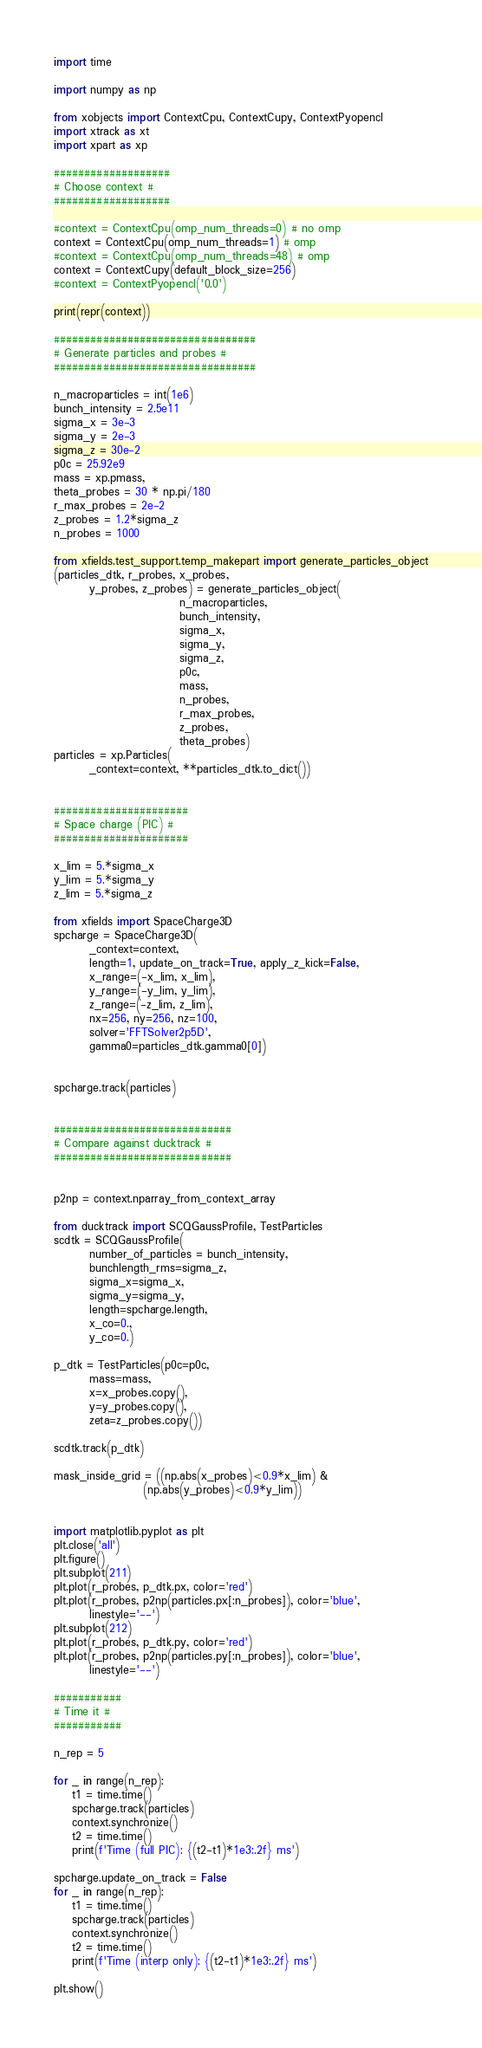<code> <loc_0><loc_0><loc_500><loc_500><_Python_>import time

import numpy as np

from xobjects import ContextCpu, ContextCupy, ContextPyopencl
import xtrack as xt
import xpart as xp

###################
# Choose context #
###################

#context = ContextCpu(omp_num_threads=0) # no omp
context = ContextCpu(omp_num_threads=1) # omp
#context = ContextCpu(omp_num_threads=48) # omp
context = ContextCupy(default_block_size=256)
#context = ContextPyopencl('0.0')

print(repr(context))

#################################
# Generate particles and probes #
#################################

n_macroparticles = int(1e6)
bunch_intensity = 2.5e11
sigma_x = 3e-3
sigma_y = 2e-3
sigma_z = 30e-2
p0c = 25.92e9
mass = xp.pmass,
theta_probes = 30 * np.pi/180
r_max_probes = 2e-2
z_probes = 1.2*sigma_z
n_probes = 1000

from xfields.test_support.temp_makepart import generate_particles_object
(particles_dtk, r_probes, x_probes,
        y_probes, z_probes) = generate_particles_object(
                            n_macroparticles,
                            bunch_intensity,
                            sigma_x,
                            sigma_y,
                            sigma_z,
                            p0c,
                            mass,
                            n_probes,
                            r_max_probes,
                            z_probes,
                            theta_probes)
particles = xp.Particles(
        _context=context, **particles_dtk.to_dict())


######################
# Space charge (PIC) #
######################

x_lim = 5.*sigma_x
y_lim = 5.*sigma_y
z_lim = 5.*sigma_z

from xfields import SpaceCharge3D
spcharge = SpaceCharge3D(
        _context=context,
        length=1, update_on_track=True, apply_z_kick=False,
        x_range=(-x_lim, x_lim),
        y_range=(-y_lim, y_lim),
        z_range=(-z_lim, z_lim),
        nx=256, ny=256, nz=100,
        solver='FFTSolver2p5D',
        gamma0=particles_dtk.gamma0[0])


spcharge.track(particles)


#############################
# Compare against ducktrack #
#############################


p2np = context.nparray_from_context_array

from ducktrack import SCQGaussProfile, TestParticles
scdtk = SCQGaussProfile(
        number_of_particles = bunch_intensity,
        bunchlength_rms=sigma_z,
        sigma_x=sigma_x,
        sigma_y=sigma_y,
        length=spcharge.length,
        x_co=0.,
        y_co=0.)

p_dtk = TestParticles(p0c=p0c,
        mass=mass,
        x=x_probes.copy(),
        y=y_probes.copy(),
        zeta=z_probes.copy())

scdtk.track(p_dtk)

mask_inside_grid = ((np.abs(x_probes)<0.9*x_lim) &
                    (np.abs(y_probes)<0.9*y_lim))


import matplotlib.pyplot as plt
plt.close('all')
plt.figure()
plt.subplot(211)
plt.plot(r_probes, p_dtk.px, color='red')
plt.plot(r_probes, p2np(particles.px[:n_probes]), color='blue',
        linestyle='--')
plt.subplot(212)
plt.plot(r_probes, p_dtk.py, color='red')
plt.plot(r_probes, p2np(particles.py[:n_probes]), color='blue',
        linestyle='--')

###########
# Time it #
###########

n_rep = 5

for _ in range(n_rep):
    t1 = time.time()
    spcharge.track(particles)
    context.synchronize()
    t2 = time.time()
    print(f'Time (full PIC): {(t2-t1)*1e3:.2f} ms')

spcharge.update_on_track = False
for _ in range(n_rep):
    t1 = time.time()
    spcharge.track(particles)
    context.synchronize()
    t2 = time.time()
    print(f'Time (interp only): {(t2-t1)*1e3:.2f} ms')

plt.show()
</code> 